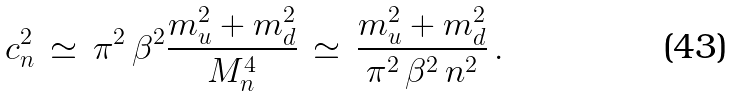Convert formula to latex. <formula><loc_0><loc_0><loc_500><loc_500>c _ { n } ^ { 2 } \, \simeq \, \pi ^ { 2 } \, \beta ^ { 2 } \frac { m _ { u } ^ { 2 } + m _ { d } ^ { 2 } } { M _ { n } ^ { 4 } } \, \simeq \, \frac { m _ { u } ^ { 2 } + m _ { d } ^ { 2 } } { \pi ^ { 2 } \, \beta ^ { 2 } \, n ^ { 2 } } \, .</formula> 